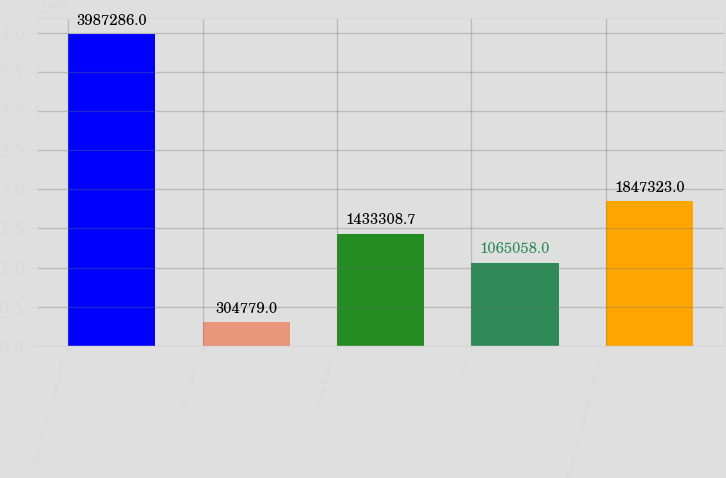<chart> <loc_0><loc_0><loc_500><loc_500><bar_chart><fcel>Interconnect Products and<fcel>Cable Products<fcel>United States<fcel>China<fcel>Other International Locations<nl><fcel>3.98729e+06<fcel>304779<fcel>1.43331e+06<fcel>1.06506e+06<fcel>1.84732e+06<nl></chart> 